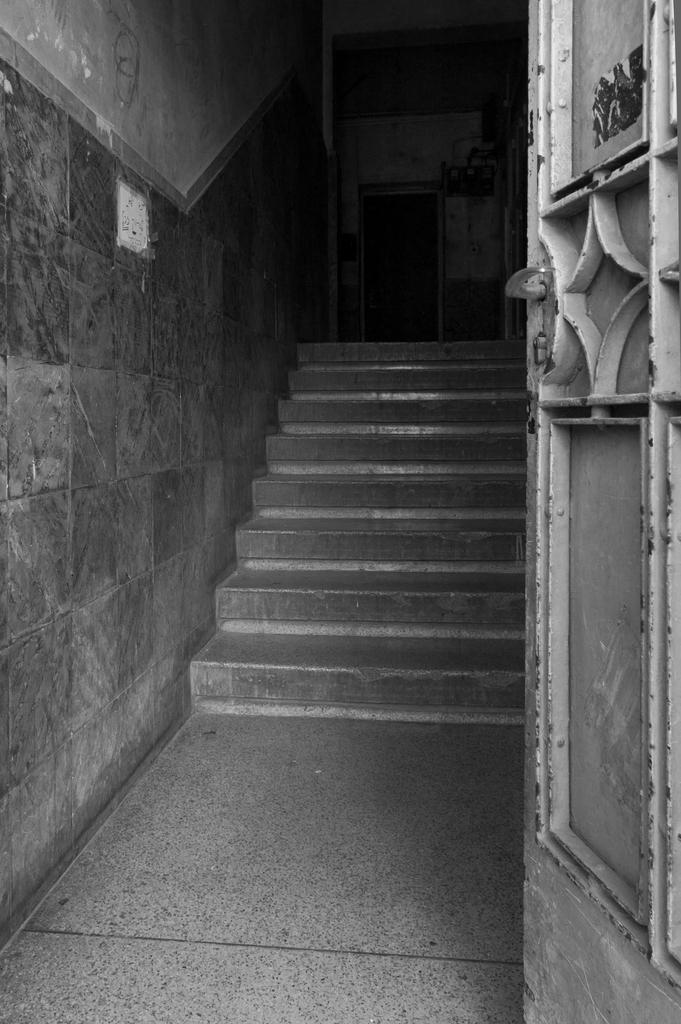In one or two sentences, can you explain what this image depicts? This is a black and white picture. We can see stairs, wall and this is a door. 